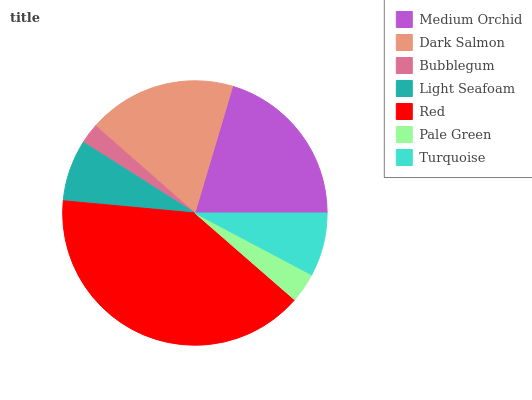Is Bubblegum the minimum?
Answer yes or no. Yes. Is Red the maximum?
Answer yes or no. Yes. Is Dark Salmon the minimum?
Answer yes or no. No. Is Dark Salmon the maximum?
Answer yes or no. No. Is Medium Orchid greater than Dark Salmon?
Answer yes or no. Yes. Is Dark Salmon less than Medium Orchid?
Answer yes or no. Yes. Is Dark Salmon greater than Medium Orchid?
Answer yes or no. No. Is Medium Orchid less than Dark Salmon?
Answer yes or no. No. Is Turquoise the high median?
Answer yes or no. Yes. Is Turquoise the low median?
Answer yes or no. Yes. Is Bubblegum the high median?
Answer yes or no. No. Is Dark Salmon the low median?
Answer yes or no. No. 